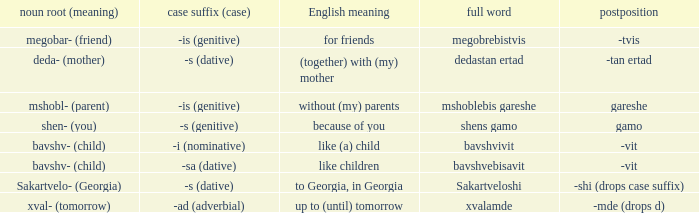What is Case Suffix (Case), when Postposition is "-mde (drops d)"? -ad (adverbial). 